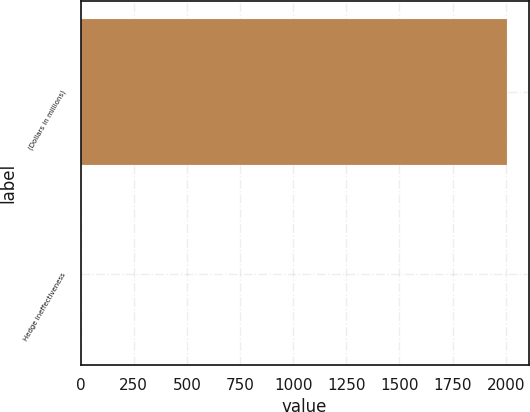Convert chart. <chart><loc_0><loc_0><loc_500><loc_500><bar_chart><fcel>(Dollars in millions)<fcel>Hedge ineffectiveness<nl><fcel>2007<fcel>4<nl></chart> 